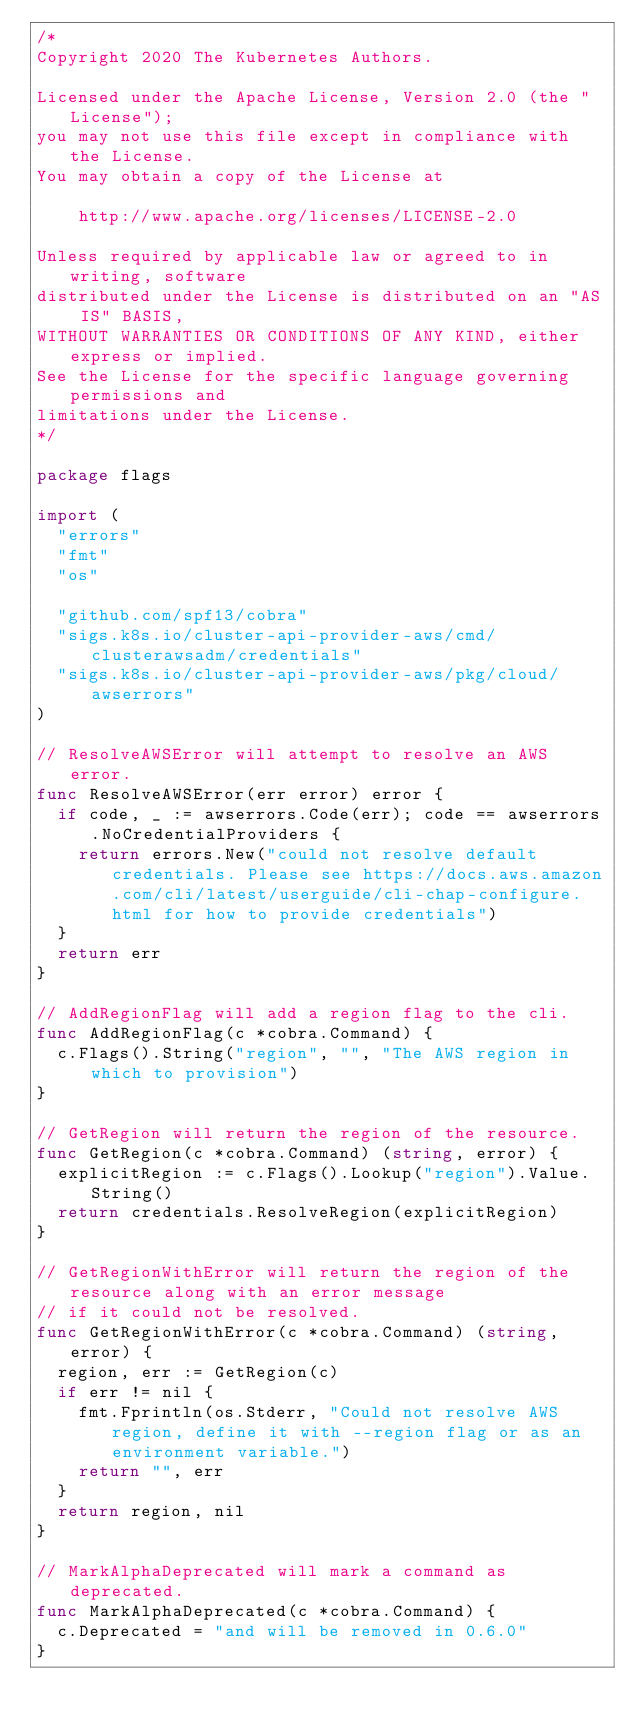Convert code to text. <code><loc_0><loc_0><loc_500><loc_500><_Go_>/*
Copyright 2020 The Kubernetes Authors.

Licensed under the Apache License, Version 2.0 (the "License");
you may not use this file except in compliance with the License.
You may obtain a copy of the License at

    http://www.apache.org/licenses/LICENSE-2.0

Unless required by applicable law or agreed to in writing, software
distributed under the License is distributed on an "AS IS" BASIS,
WITHOUT WARRANTIES OR CONDITIONS OF ANY KIND, either express or implied.
See the License for the specific language governing permissions and
limitations under the License.
*/

package flags

import (
	"errors"
	"fmt"
	"os"

	"github.com/spf13/cobra"
	"sigs.k8s.io/cluster-api-provider-aws/cmd/clusterawsadm/credentials"
	"sigs.k8s.io/cluster-api-provider-aws/pkg/cloud/awserrors"
)

// ResolveAWSError will attempt to resolve an AWS error.
func ResolveAWSError(err error) error {
	if code, _ := awserrors.Code(err); code == awserrors.NoCredentialProviders {
		return errors.New("could not resolve default credentials. Please see https://docs.aws.amazon.com/cli/latest/userguide/cli-chap-configure.html for how to provide credentials")
	}
	return err
}

// AddRegionFlag will add a region flag to the cli.
func AddRegionFlag(c *cobra.Command) {
	c.Flags().String("region", "", "The AWS region in which to provision")
}

// GetRegion will return the region of the resource.
func GetRegion(c *cobra.Command) (string, error) {
	explicitRegion := c.Flags().Lookup("region").Value.String()
	return credentials.ResolveRegion(explicitRegion)
}

// GetRegionWithError will return the region of the resource along with an error message
// if it could not be resolved.
func GetRegionWithError(c *cobra.Command) (string, error) {
	region, err := GetRegion(c)
	if err != nil {
		fmt.Fprintln(os.Stderr, "Could not resolve AWS region, define it with --region flag or as an environment variable.")
		return "", err
	}
	return region, nil
}

// MarkAlphaDeprecated will mark a command as deprecated.
func MarkAlphaDeprecated(c *cobra.Command) {
	c.Deprecated = "and will be removed in 0.6.0"
}
</code> 